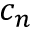<formula> <loc_0><loc_0><loc_500><loc_500>c _ { n }</formula> 